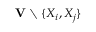<formula> <loc_0><loc_0><loc_500><loc_500>V \ \{ X _ { i } , X _ { j } \}</formula> 